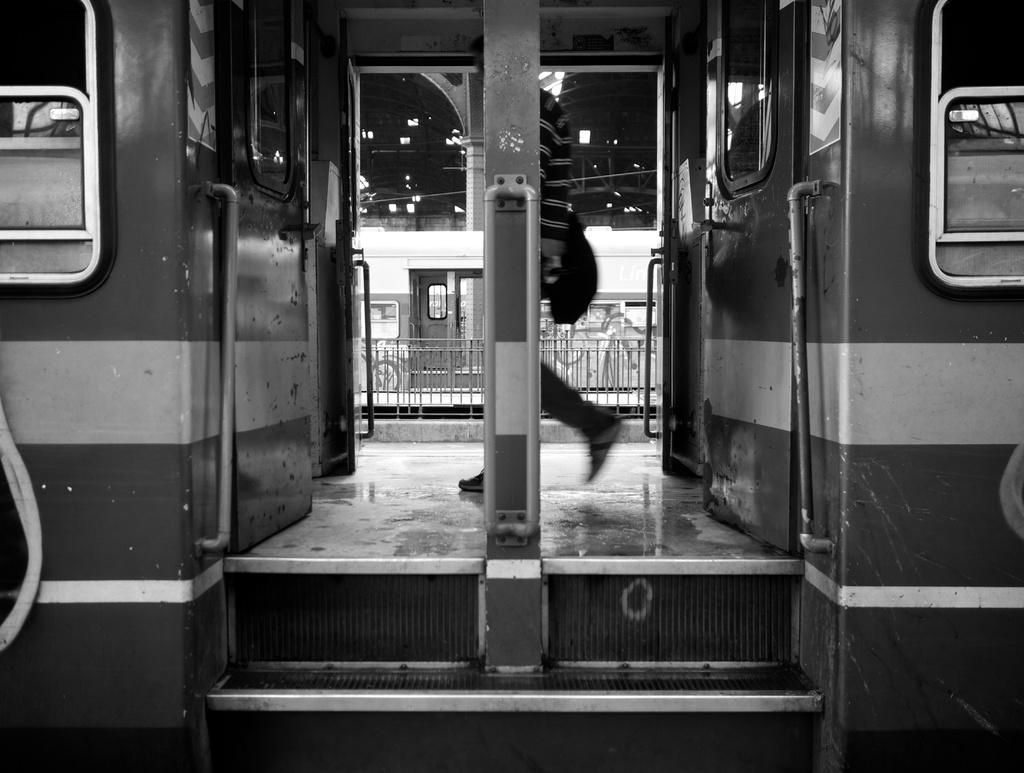What is the color scheme of the image? The image is black and white. What is the main subject of the image? The image appears to depict a coach. What is happening inside the coach? There is a person walking inside the coach. What can be seen in the background of the image? There is another coach, a roof, pillars, and iron grilles visible in the background. What type of trees can be seen in the image? There are no trees visible in the image. What grade is the carpenter working on in the image? There is no carpenter or any indication of a grade in the image. 